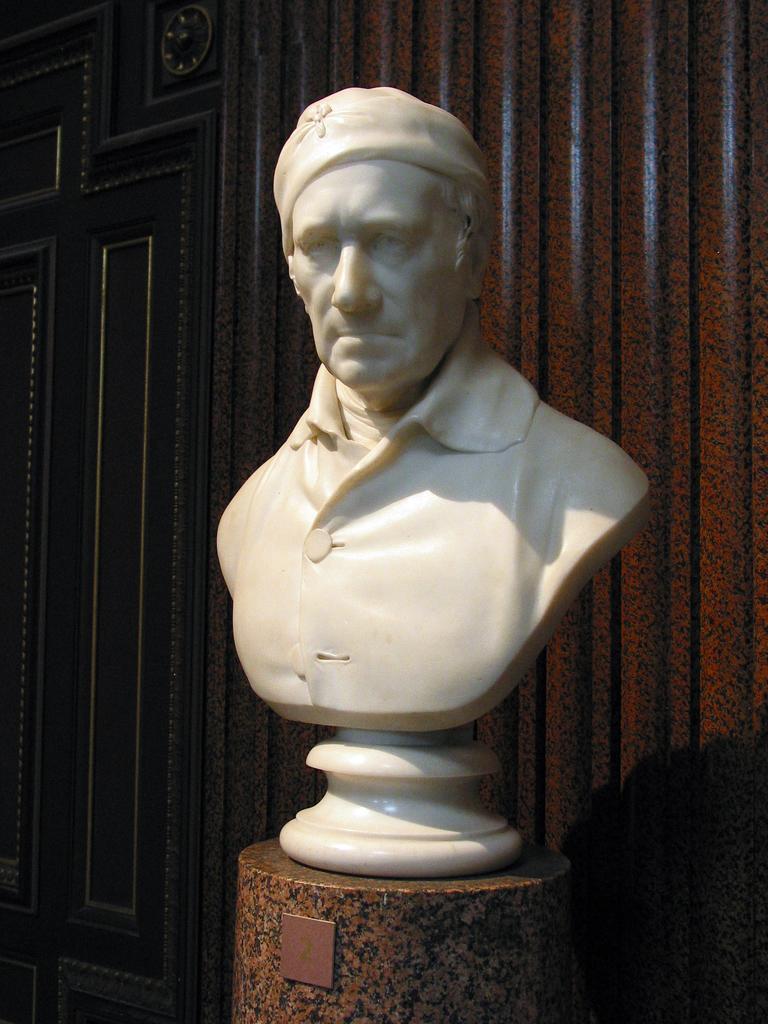Can you describe this image briefly? In the center of the image there is a statue placed on the table. In the background there is a wall. 